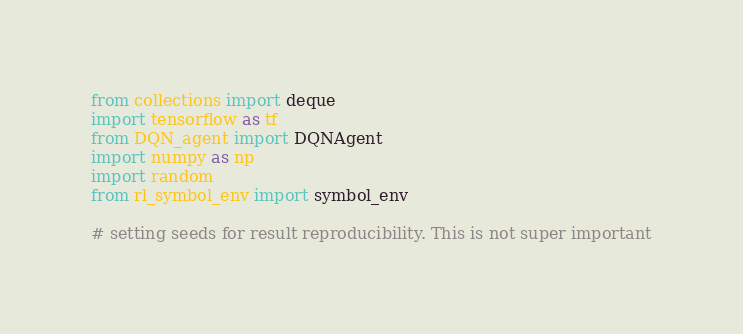Convert code to text. <code><loc_0><loc_0><loc_500><loc_500><_Python_>from collections import deque
import tensorflow as tf
from DQN_agent import DQNAgent
import numpy as np
import random
from rl_symbol_env import symbol_env

# setting seeds for result reproducibility. This is not super important</code> 